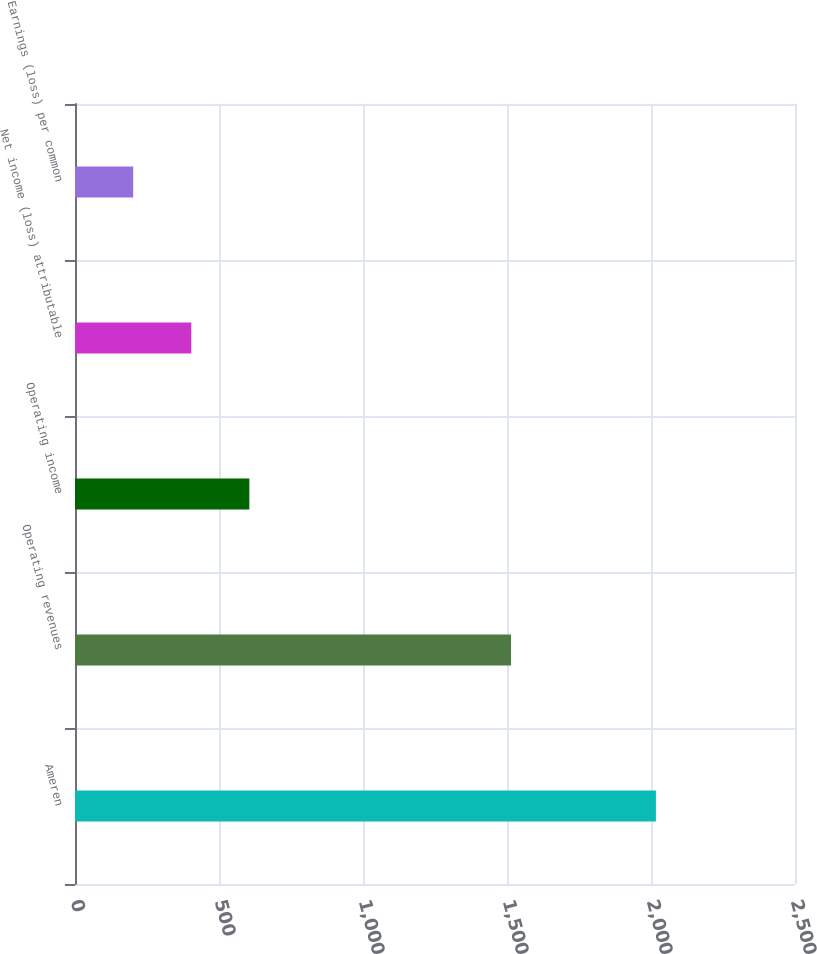Convert chart. <chart><loc_0><loc_0><loc_500><loc_500><bar_chart><fcel>Ameren<fcel>Operating revenues<fcel>Operating income<fcel>Net income (loss) attributable<fcel>Earnings (loss) per common<nl><fcel>2017<fcel>1514<fcel>605.4<fcel>403.74<fcel>202.08<nl></chart> 